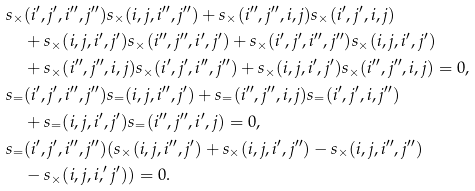Convert formula to latex. <formula><loc_0><loc_0><loc_500><loc_500>s _ { \times } & ( i ^ { \prime } , j ^ { \prime } , i ^ { \prime \prime } , j ^ { \prime \prime } ) s _ { \times } ( i , j , i ^ { \prime \prime } , j ^ { \prime \prime } ) + s _ { \times } ( i ^ { \prime \prime } , j ^ { \prime \prime } , i , j ) s _ { \times } ( i ^ { \prime } , j ^ { \prime } , i , j ) \\ & + s _ { \times } ( i , j , i ^ { \prime } , j ^ { \prime } ) s _ { \times } ( i ^ { \prime \prime } , j ^ { \prime \prime } , i ^ { \prime } , j ^ { \prime } ) + s _ { \times } ( i ^ { \prime } , j ^ { \prime } , i ^ { \prime \prime } , j ^ { \prime \prime } ) s _ { \times } ( i , j , i ^ { \prime } , j ^ { \prime } ) \\ & + s _ { \times } ( i ^ { \prime \prime } , j ^ { \prime \prime } , i , j ) s _ { \times } ( i ^ { \prime } , j ^ { \prime } , i ^ { \prime \prime } , j ^ { \prime \prime } ) + s _ { \times } ( i , j , i ^ { \prime } , j ^ { \prime } ) s _ { \times } ( i ^ { \prime \prime } , j ^ { \prime \prime } , i , j ) = 0 , \\ s _ { = } & ( i ^ { \prime } , j ^ { \prime } , i ^ { \prime \prime } , j ^ { \prime \prime } ) s _ { = } ( i , j , i ^ { \prime \prime } , j ^ { \prime } ) + s _ { = } ( i ^ { \prime \prime } , j ^ { \prime \prime } , i , j ) s _ { = } ( i ^ { \prime } , j ^ { \prime } , i , j ^ { \prime \prime } ) \\ & + s _ { = } ( i , j , i ^ { \prime } , j ^ { \prime } ) s _ { = } ( i ^ { \prime \prime } , j ^ { \prime \prime } , i ^ { \prime } , j ) = 0 , \\ s _ { = } & ( i ^ { \prime } , j ^ { \prime } , i ^ { \prime \prime } , j ^ { \prime \prime } ) ( s _ { \times } ( i , j , i ^ { \prime \prime } , j ^ { \prime } ) + s _ { \times } ( i , j , i ^ { \prime } , j ^ { \prime \prime } ) - s _ { \times } ( i , j , i ^ { \prime \prime } , j ^ { \prime \prime } ) \\ & - s _ { \times } ( i , j , i , ^ { \prime } j ^ { \prime } ) ) = 0 .</formula> 